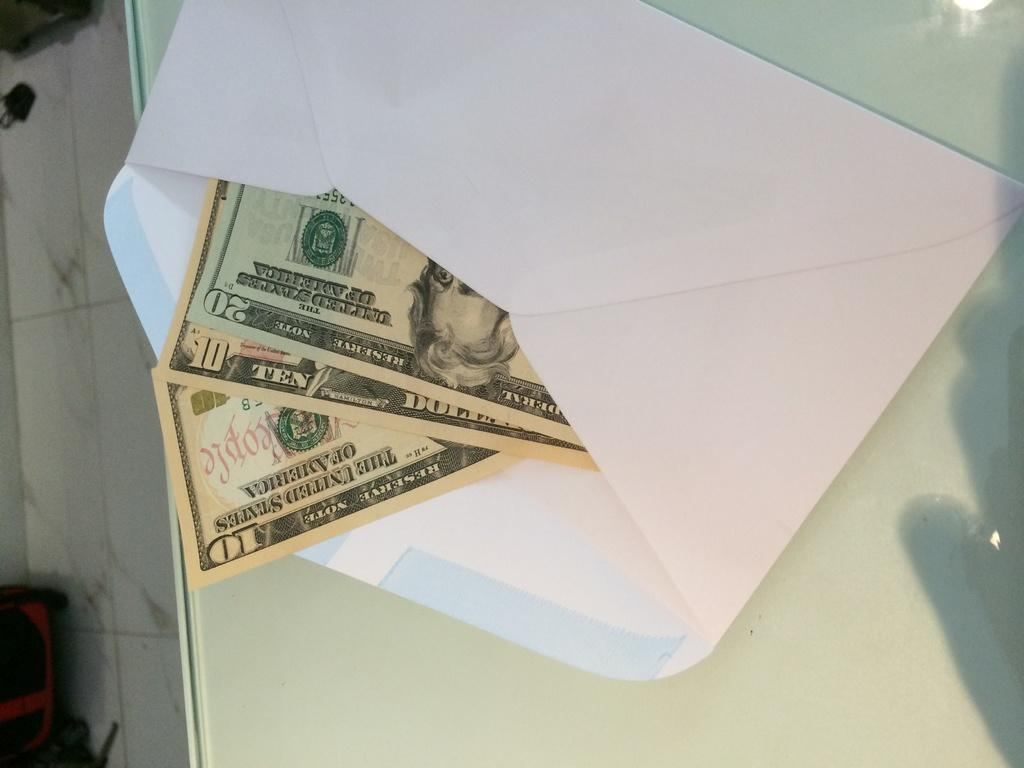<image>
Share a concise interpretation of the image provided. an envelope with three bills inside, two tens and one twenty 